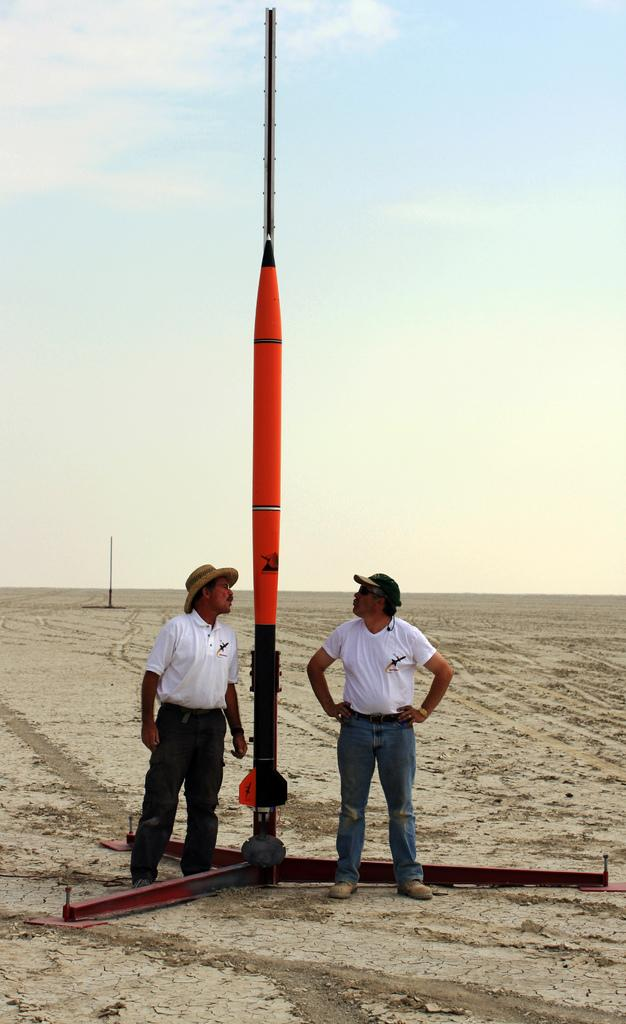How many people are in the image? There are two persons standing in the image. What are the persons doing in the image? The persons are standing on a surface. What is in the middle of the two persons? There is a pole in the middle of the two persons. What can be seen in the background of the image? There is a sky visible in the background of the image. What type of humor can be seen in the image? There is no humor present in the image; it simply shows two persons standing with a pole between them. What shape is the pole in the image? The facts provided do not give information about the shape of the pole. However, based on the image, it appears to be a straight pole. 